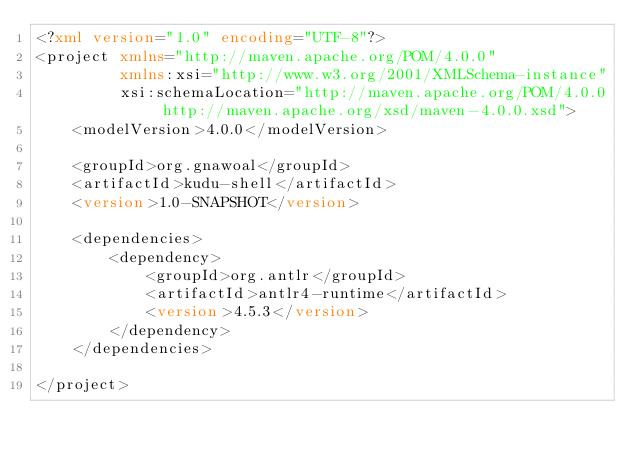<code> <loc_0><loc_0><loc_500><loc_500><_XML_><?xml version="1.0" encoding="UTF-8"?>
<project xmlns="http://maven.apache.org/POM/4.0.0"
         xmlns:xsi="http://www.w3.org/2001/XMLSchema-instance"
         xsi:schemaLocation="http://maven.apache.org/POM/4.0.0 http://maven.apache.org/xsd/maven-4.0.0.xsd">
    <modelVersion>4.0.0</modelVersion>

    <groupId>org.gnawoal</groupId>
    <artifactId>kudu-shell</artifactId>
    <version>1.0-SNAPSHOT</version>

    <dependencies>
        <dependency>
            <groupId>org.antlr</groupId>
            <artifactId>antlr4-runtime</artifactId>
            <version>4.5.3</version>
        </dependency>
    </dependencies>

</project></code> 